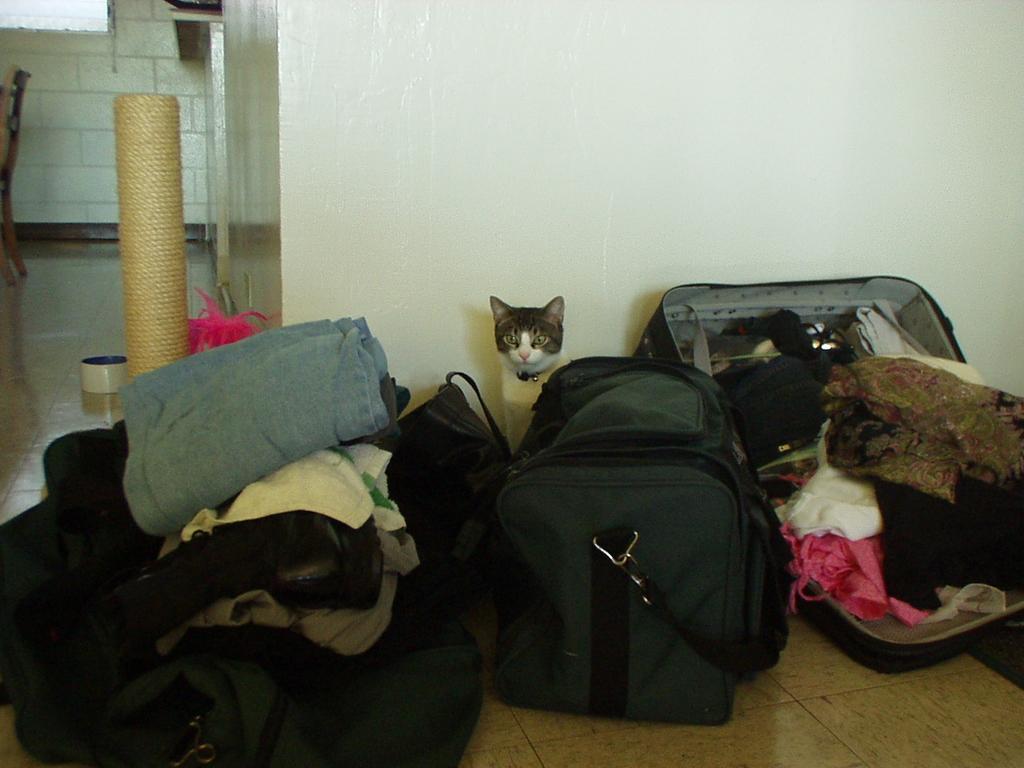Can you describe this image briefly? In this image there are some luggage and backpacks are there and on the right side of the image there is one bag pack and in that bag pack there are some clothes and in the middle of the image there is one cat and on the left side of the image there is one wall and chair and window are there and on the left side there is one rope and in the top of the image there is one wall. 